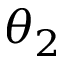<formula> <loc_0><loc_0><loc_500><loc_500>\theta _ { 2 }</formula> 